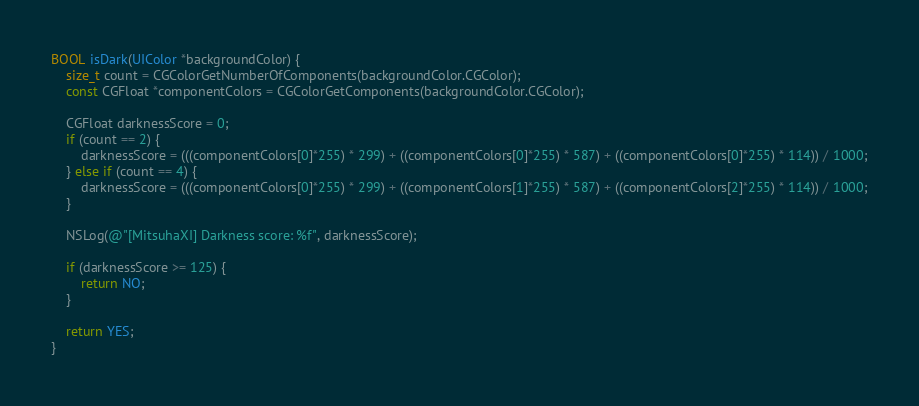<code> <loc_0><loc_0><loc_500><loc_500><_ObjectiveC_>BOOL isDark(UIColor *backgroundColor) {
    size_t count = CGColorGetNumberOfComponents(backgroundColor.CGColor);
    const CGFloat *componentColors = CGColorGetComponents(backgroundColor.CGColor);

    CGFloat darknessScore = 0;
    if (count == 2) {
        darknessScore = (((componentColors[0]*255) * 299) + ((componentColors[0]*255) * 587) + ((componentColors[0]*255) * 114)) / 1000;
    } else if (count == 4) {
        darknessScore = (((componentColors[0]*255) * 299) + ((componentColors[1]*255) * 587) + ((componentColors[2]*255) * 114)) / 1000;
    }

    NSLog(@"[MitsuhaXI] Darkness score: %f", darknessScore);

    if (darknessScore >= 125) {
        return NO;
    }

    return YES;
}</code> 